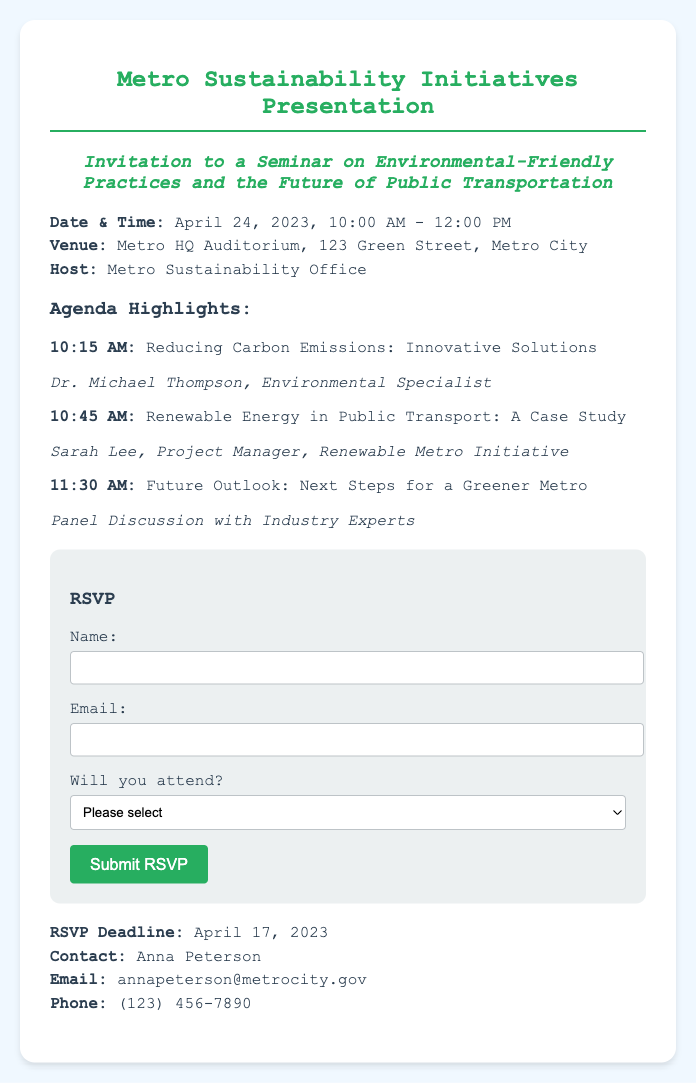What is the date of the seminar? The date of the seminar is explicitly stated in the document as April 24, 2023.
Answer: April 24, 2023 What time does the seminar start? The seminar start time is specified in the document as 10:00 AM.
Answer: 10:00 AM Who is the host of the event? The host of the event, as mentioned, is the Metro Sustainability Office.
Answer: Metro Sustainability Office What is the RSVP deadline? The RSVP deadline is clearly indicated in the document as April 17, 2023.
Answer: April 17, 2023 What is one topic discussed during the seminar? The document lists several topics; one topic mentioned is "Reducing Carbon Emissions: Innovative Solutions."
Answer: Reducing Carbon Emissions: Innovative Solutions What is the venue for the seminar? The venue for the seminar is detailed in the document as Metro HQ Auditorium, 123 Green Street, Metro City.
Answer: Metro HQ Auditorium, 123 Green Street, Metro City Is this seminar focused on public transportation? The title and description indicate that the seminar is about environmental-friendly practices specifically in public transportation.
Answer: Yes How can participants contact for more information? The document provides contact information for Anna Peterson for inquiries.
Answer: Anna Peterson 